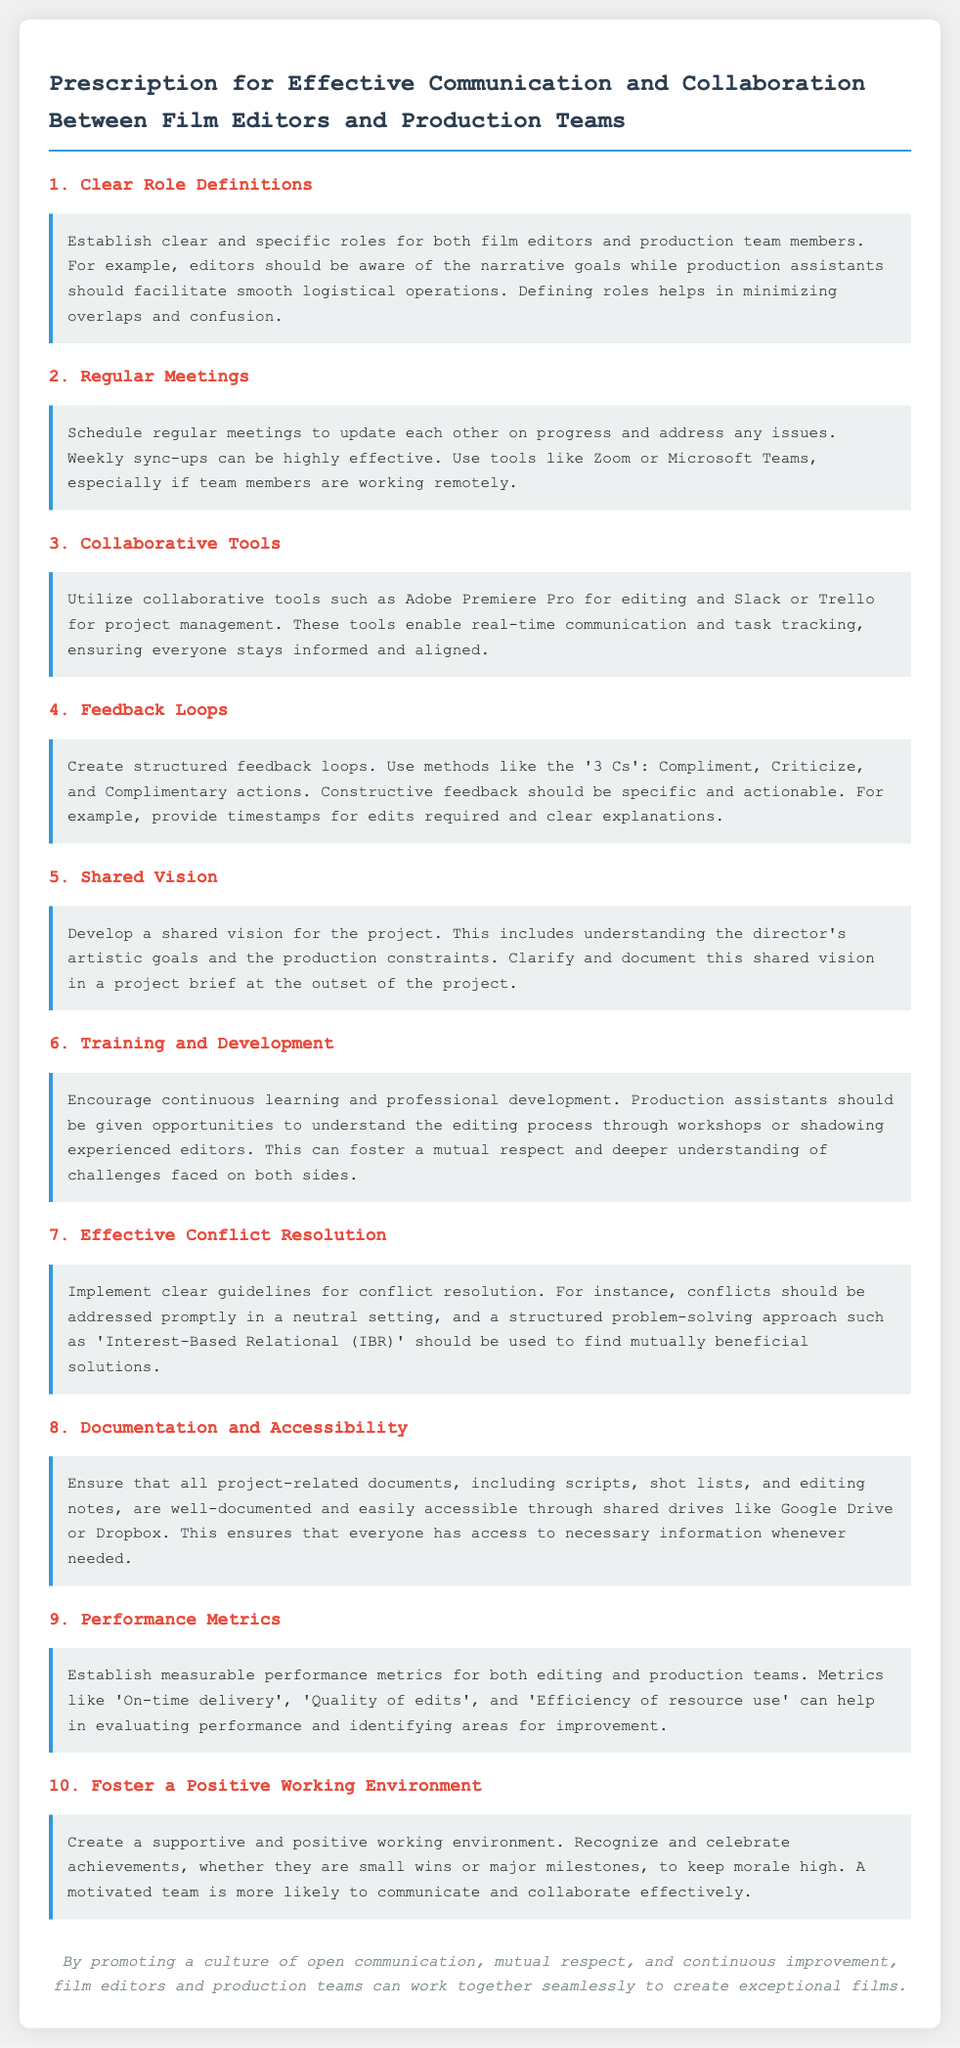What is the title of the document? The title is stated at the top of the document in a prominent manner.
Answer: Prescription for Effective Communication and Collaboration Between Film Editors and Production Teams How many main sections are in the document? The document clearly has numbered sections that outline the topics covered.
Answer: 10 What tool is suggested for project management? A specific tool is mentioned in the document for managing projects.
Answer: Trello What method is used for creating feedback loops? The document outlines a specific approach to give constructive feedback.
Answer: 3 Cs What should be implemented for conflict resolution? The document describes a structured approach to handle conflicts.
Answer: Interest-Based Relational (IBR) What kind of environment should be fostered? The document emphasizes the importance of a specific type of workplace atmosphere.
Answer: Positive working environment 